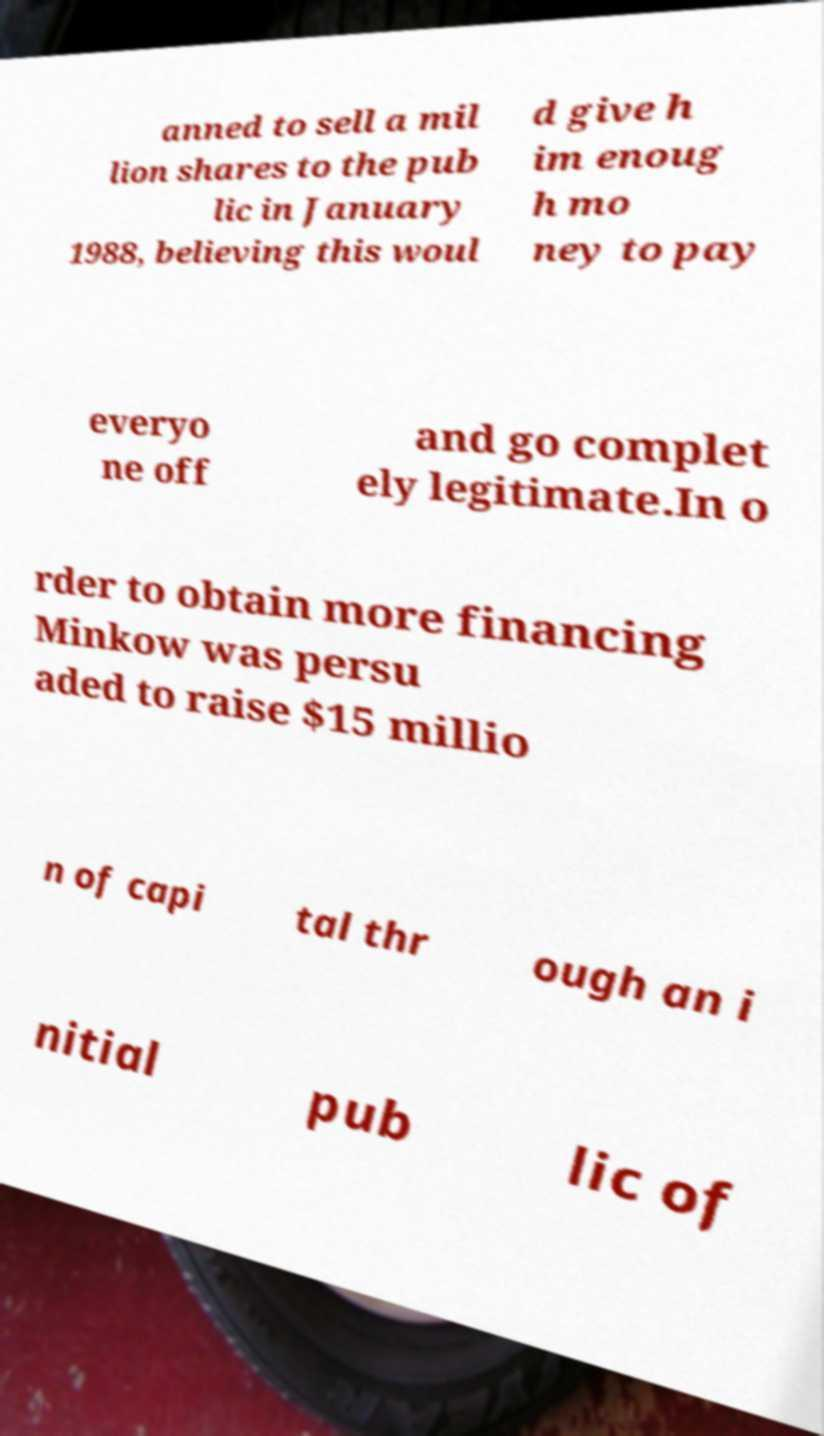Please identify and transcribe the text found in this image. anned to sell a mil lion shares to the pub lic in January 1988, believing this woul d give h im enoug h mo ney to pay everyo ne off and go complet ely legitimate.In o rder to obtain more financing Minkow was persu aded to raise $15 millio n of capi tal thr ough an i nitial pub lic of 